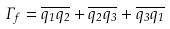Convert formula to latex. <formula><loc_0><loc_0><loc_500><loc_500>\Gamma _ { f } = \overline { q _ { 1 } q _ { 2 } } + \overline { q _ { 2 } q _ { 3 } } + \overline { q _ { 3 } q _ { 1 } }</formula> 